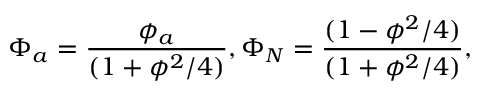<formula> <loc_0><loc_0><loc_500><loc_500>\Phi _ { a } = \frac { { \phi _ { a } } } { ( 1 + \phi ^ { 2 } / 4 ) } , \Phi _ { N } = \frac { { ( 1 - \phi ^ { 2 } / 4 ) } } { ( 1 + \phi ^ { 2 } / 4 ) } ,</formula> 